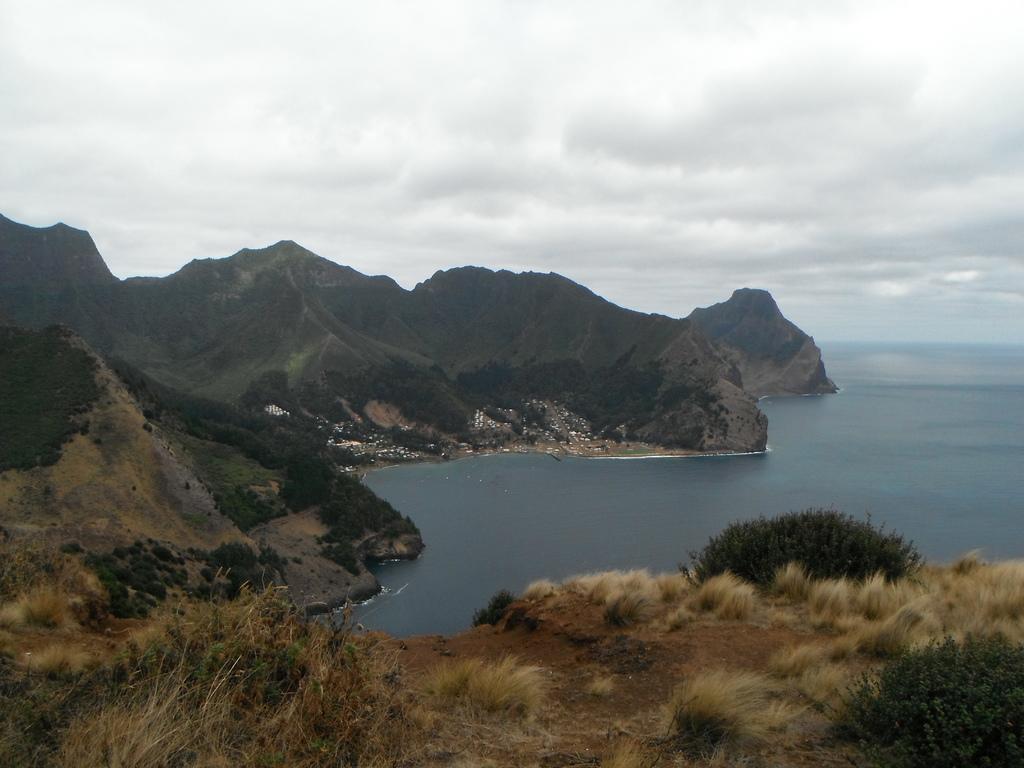How would you summarize this image in a sentence or two? These are the mountains. This looks like a dried grass. I can see the bushes. This looks like a sea with the water flowing. 